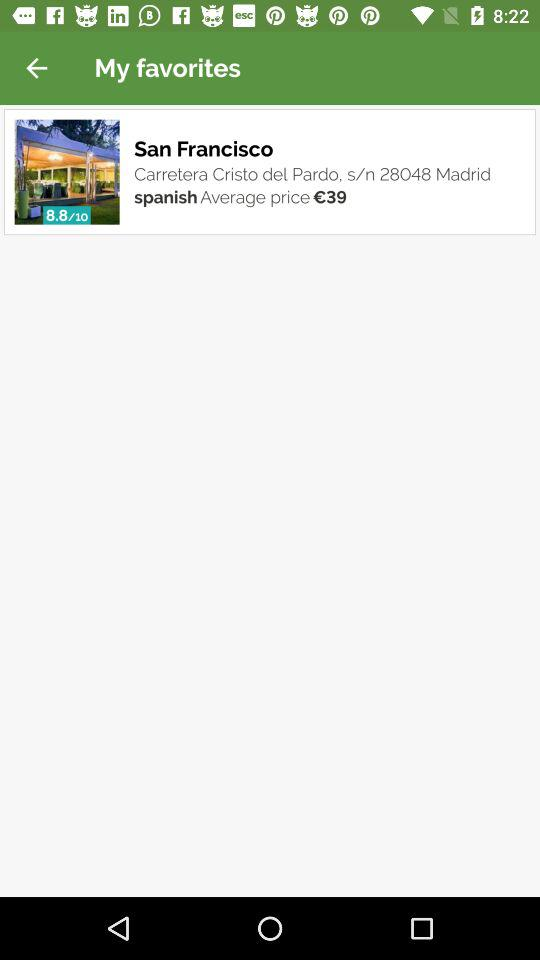What is the city name? The city name is San Francisco. 